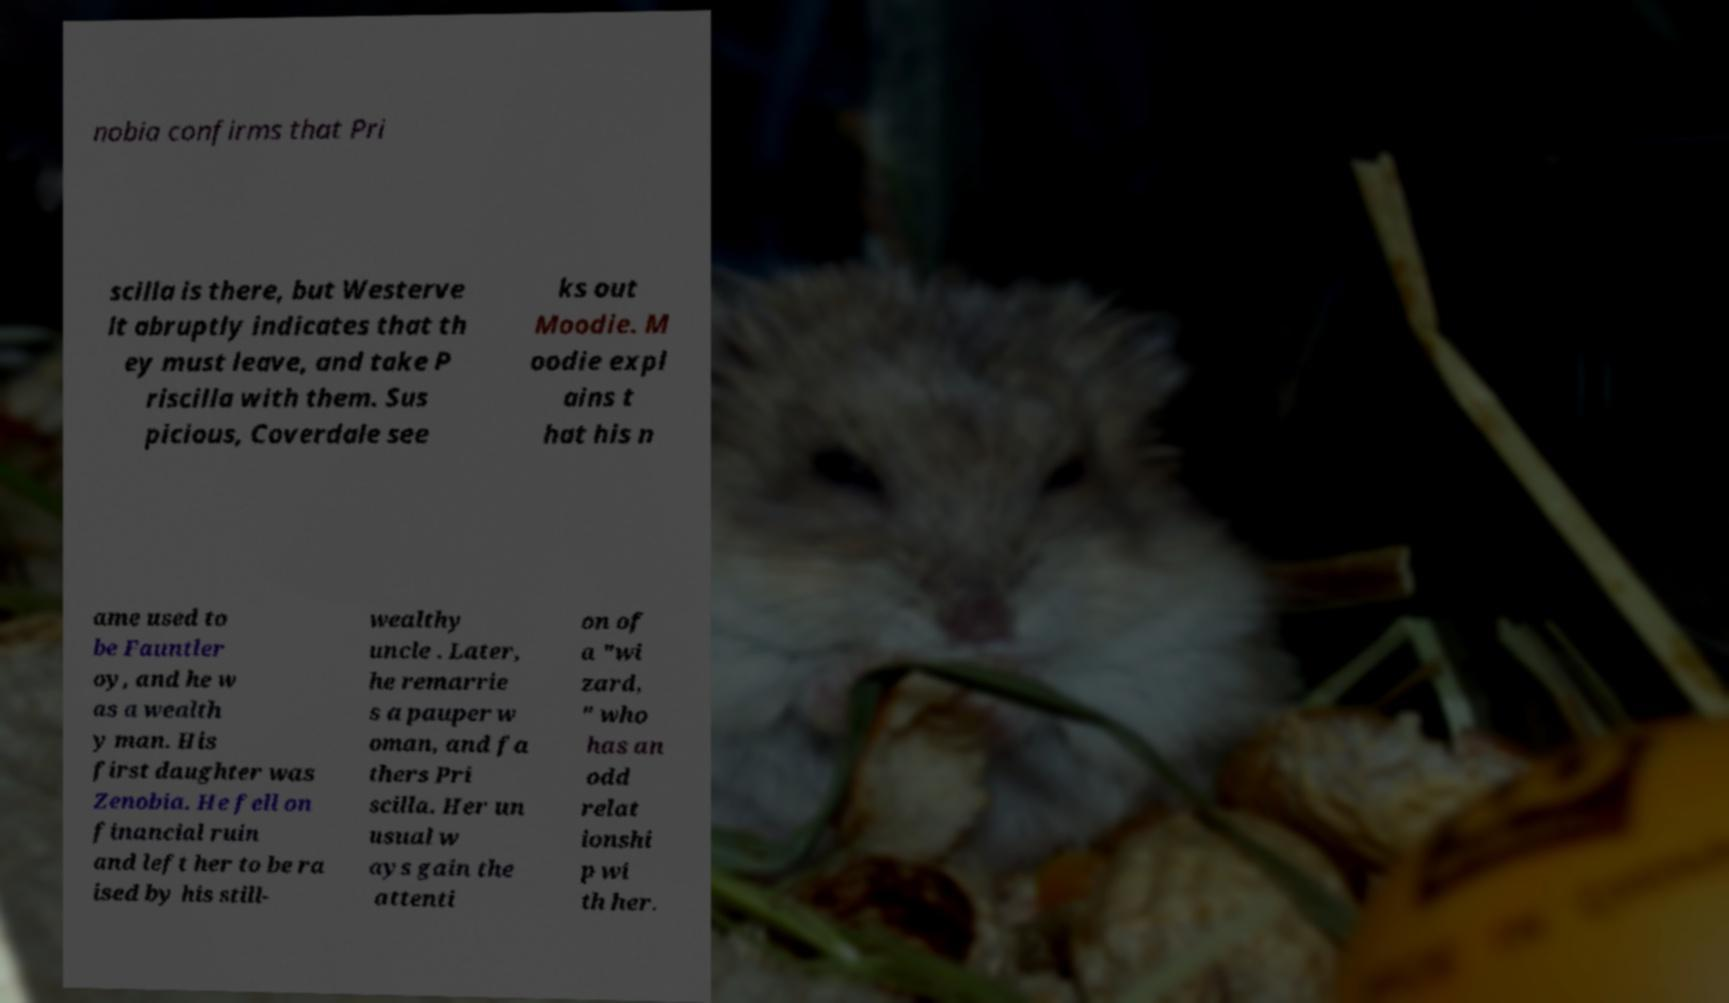Please identify and transcribe the text found in this image. nobia confirms that Pri scilla is there, but Westerve lt abruptly indicates that th ey must leave, and take P riscilla with them. Sus picious, Coverdale see ks out Moodie. M oodie expl ains t hat his n ame used to be Fauntler oy, and he w as a wealth y man. His first daughter was Zenobia. He fell on financial ruin and left her to be ra ised by his still- wealthy uncle . Later, he remarrie s a pauper w oman, and fa thers Pri scilla. Her un usual w ays gain the attenti on of a "wi zard, " who has an odd relat ionshi p wi th her. 